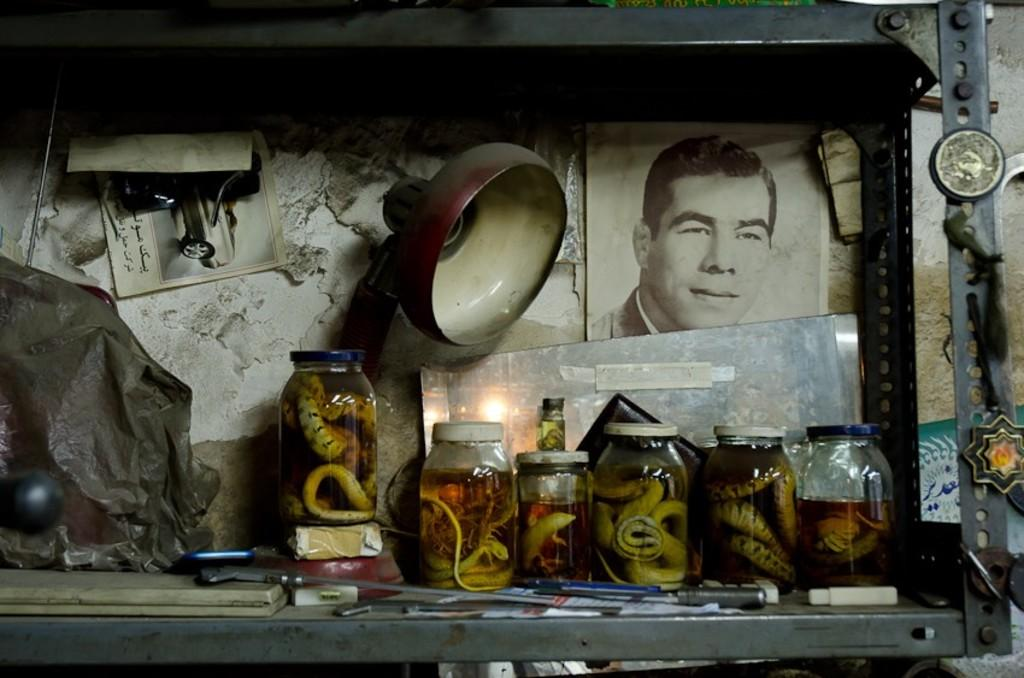What is located in the center of the image? There is a rack in the center of the image. What is contained within the rack? The rack contains snake bottles. What type of lighting is present in the image? There is a lamp in the image. What can be seen on the wall in the image? There are photographs on the wall in the image. How many ducks are sitting on the swing in the image? There are no ducks or swings present in the image. 